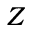<formula> <loc_0><loc_0><loc_500><loc_500>Z</formula> 